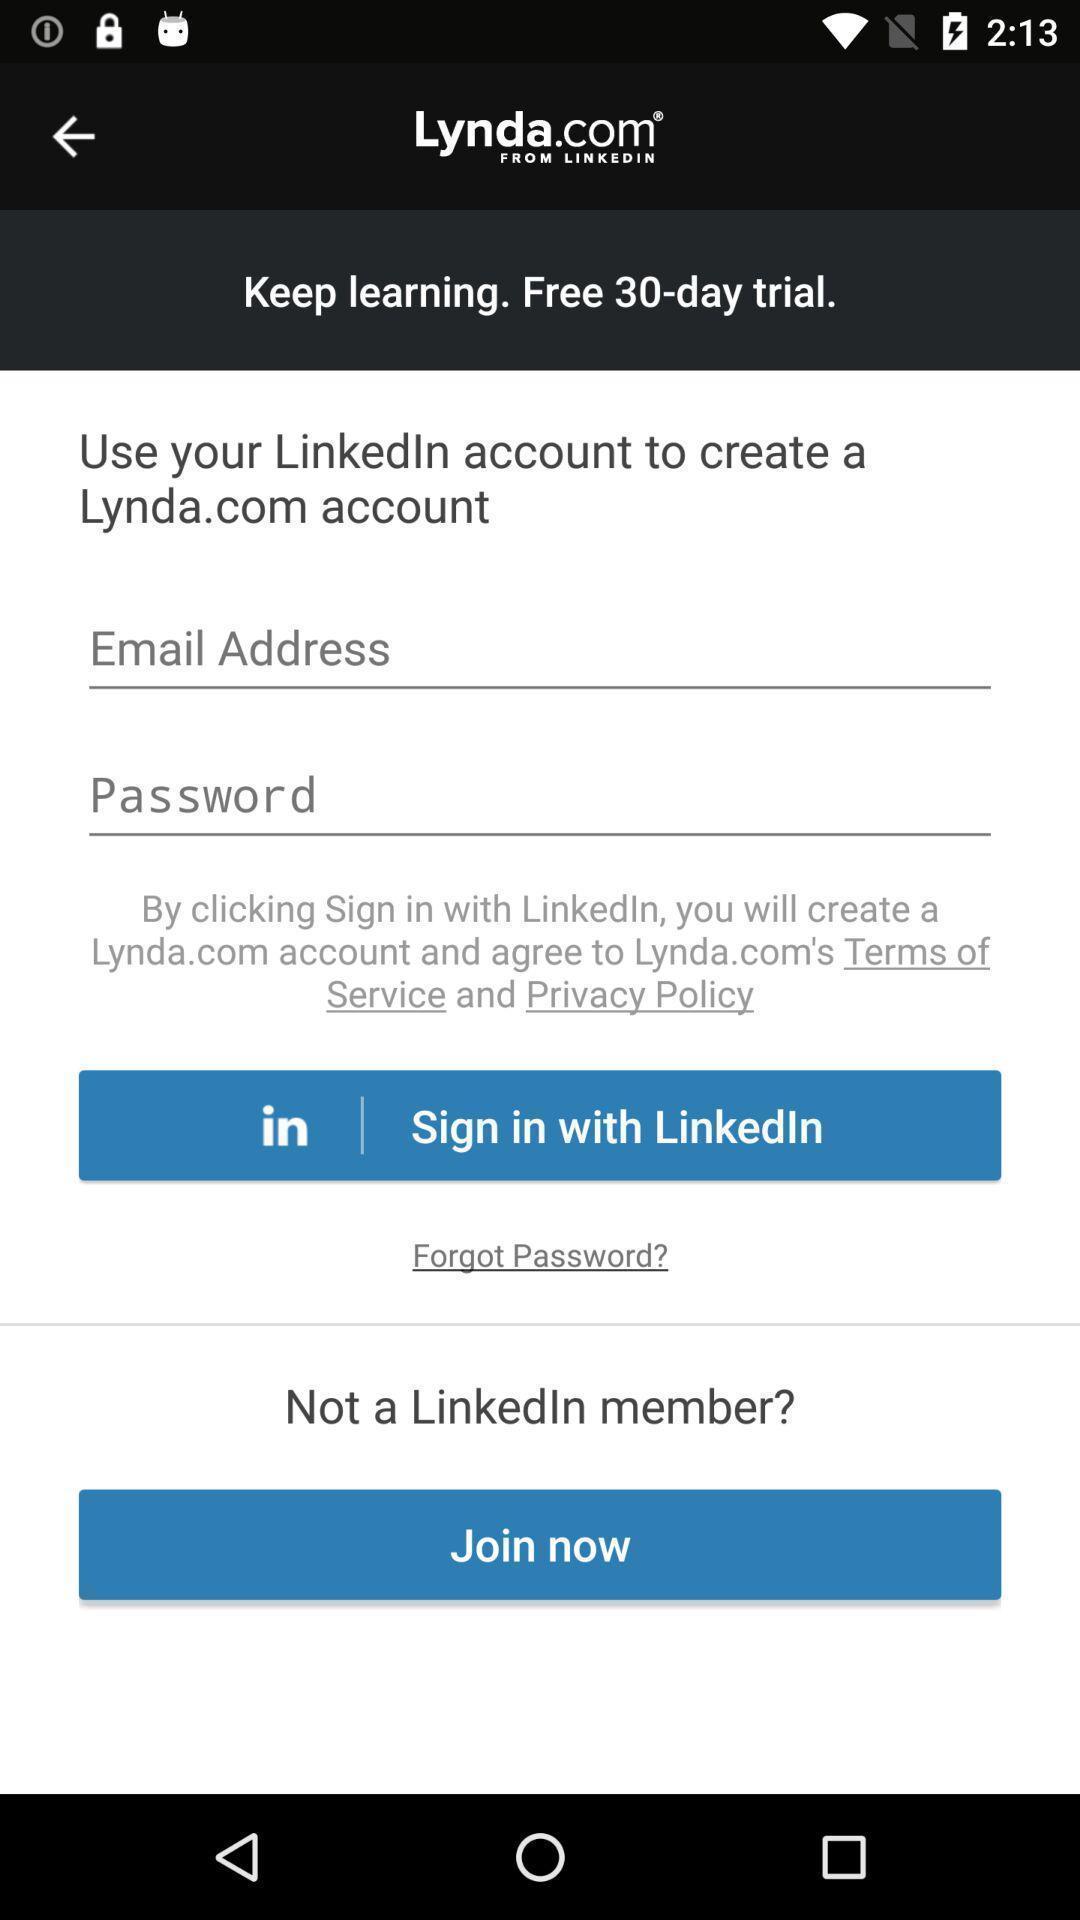Provide a description of this screenshot. Welcome page of an social app to login. 